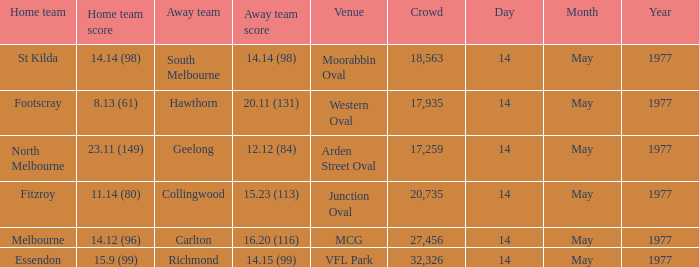I want to know the home team score of the away team of richmond that has a crowd more than 20,735 15.9 (99). 